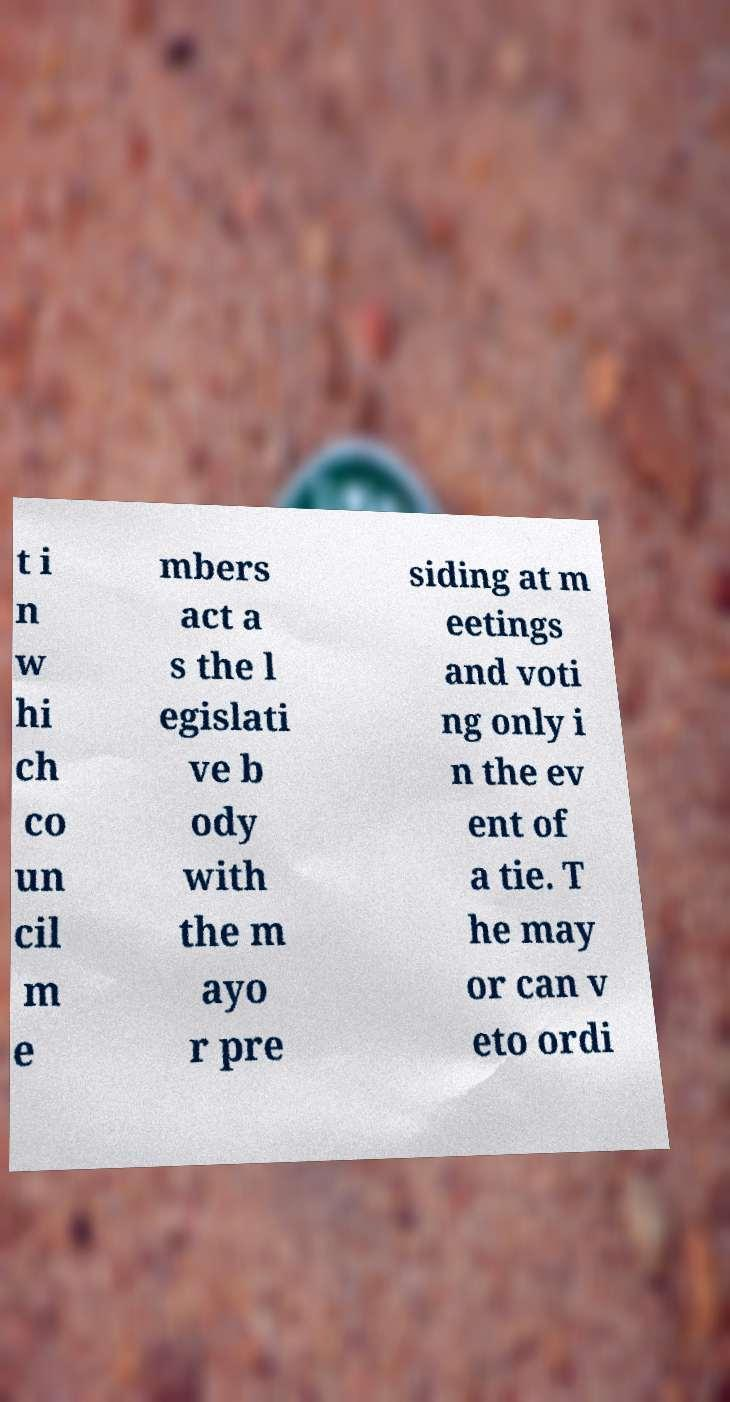Please identify and transcribe the text found in this image. t i n w hi ch co un cil m e mbers act a s the l egislati ve b ody with the m ayo r pre siding at m eetings and voti ng only i n the ev ent of a tie. T he may or can v eto ordi 